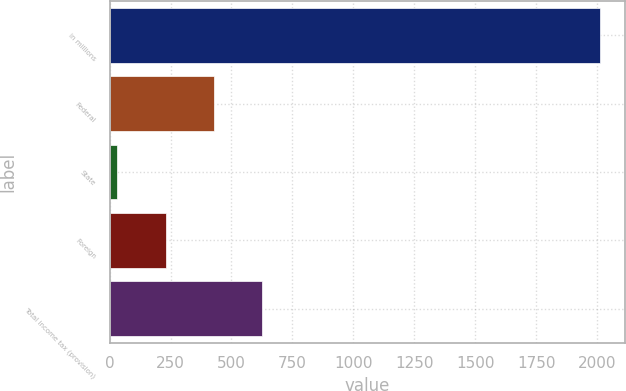Convert chart to OTSL. <chart><loc_0><loc_0><loc_500><loc_500><bar_chart><fcel>in millions<fcel>Federal<fcel>State<fcel>Foreign<fcel>Total income tax (provision)<nl><fcel>2014<fcel>427.84<fcel>31.3<fcel>229.57<fcel>626.11<nl></chart> 